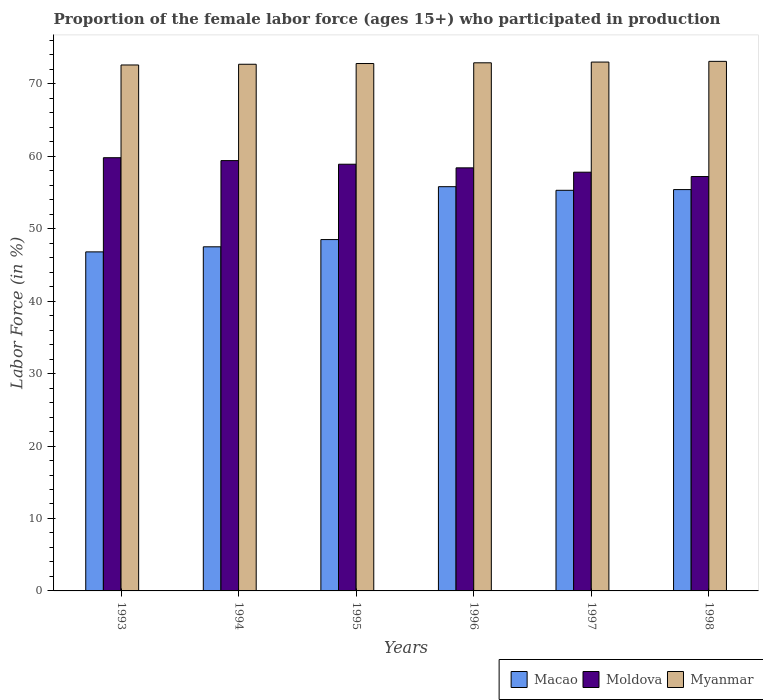How many different coloured bars are there?
Your response must be concise. 3. How many groups of bars are there?
Give a very brief answer. 6. Are the number of bars per tick equal to the number of legend labels?
Your answer should be very brief. Yes. How many bars are there on the 5th tick from the left?
Your response must be concise. 3. How many bars are there on the 6th tick from the right?
Keep it short and to the point. 3. What is the proportion of the female labor force who participated in production in Macao in 1996?
Give a very brief answer. 55.8. Across all years, what is the maximum proportion of the female labor force who participated in production in Moldova?
Ensure brevity in your answer.  59.8. Across all years, what is the minimum proportion of the female labor force who participated in production in Myanmar?
Your answer should be compact. 72.6. What is the total proportion of the female labor force who participated in production in Macao in the graph?
Offer a very short reply. 309.3. What is the difference between the proportion of the female labor force who participated in production in Myanmar in 1998 and the proportion of the female labor force who participated in production in Moldova in 1996?
Your answer should be very brief. 14.7. What is the average proportion of the female labor force who participated in production in Macao per year?
Provide a succinct answer. 51.55. In the year 1997, what is the difference between the proportion of the female labor force who participated in production in Macao and proportion of the female labor force who participated in production in Myanmar?
Offer a terse response. -17.7. In how many years, is the proportion of the female labor force who participated in production in Moldova greater than 56 %?
Provide a succinct answer. 6. What is the ratio of the proportion of the female labor force who participated in production in Myanmar in 1993 to that in 1996?
Your answer should be very brief. 1. Is the proportion of the female labor force who participated in production in Moldova in 1996 less than that in 1997?
Make the answer very short. No. What is the difference between the highest and the second highest proportion of the female labor force who participated in production in Macao?
Make the answer very short. 0.4. What does the 1st bar from the left in 1997 represents?
Provide a succinct answer. Macao. What does the 2nd bar from the right in 1996 represents?
Provide a short and direct response. Moldova. Is it the case that in every year, the sum of the proportion of the female labor force who participated in production in Macao and proportion of the female labor force who participated in production in Myanmar is greater than the proportion of the female labor force who participated in production in Moldova?
Offer a very short reply. Yes. How many years are there in the graph?
Keep it short and to the point. 6. What is the difference between two consecutive major ticks on the Y-axis?
Provide a succinct answer. 10. Does the graph contain grids?
Provide a succinct answer. No. Where does the legend appear in the graph?
Make the answer very short. Bottom right. What is the title of the graph?
Your answer should be very brief. Proportion of the female labor force (ages 15+) who participated in production. What is the Labor Force (in %) of Macao in 1993?
Your answer should be compact. 46.8. What is the Labor Force (in %) of Moldova in 1993?
Your response must be concise. 59.8. What is the Labor Force (in %) in Myanmar in 1993?
Provide a short and direct response. 72.6. What is the Labor Force (in %) of Macao in 1994?
Your answer should be very brief. 47.5. What is the Labor Force (in %) of Moldova in 1994?
Offer a terse response. 59.4. What is the Labor Force (in %) of Myanmar in 1994?
Your answer should be very brief. 72.7. What is the Labor Force (in %) in Macao in 1995?
Offer a terse response. 48.5. What is the Labor Force (in %) in Moldova in 1995?
Provide a succinct answer. 58.9. What is the Labor Force (in %) in Myanmar in 1995?
Offer a terse response. 72.8. What is the Labor Force (in %) in Macao in 1996?
Keep it short and to the point. 55.8. What is the Labor Force (in %) of Moldova in 1996?
Provide a succinct answer. 58.4. What is the Labor Force (in %) in Myanmar in 1996?
Ensure brevity in your answer.  72.9. What is the Labor Force (in %) in Macao in 1997?
Your answer should be very brief. 55.3. What is the Labor Force (in %) in Moldova in 1997?
Provide a short and direct response. 57.8. What is the Labor Force (in %) in Myanmar in 1997?
Provide a succinct answer. 73. What is the Labor Force (in %) of Macao in 1998?
Your answer should be compact. 55.4. What is the Labor Force (in %) in Moldova in 1998?
Ensure brevity in your answer.  57.2. What is the Labor Force (in %) of Myanmar in 1998?
Provide a short and direct response. 73.1. Across all years, what is the maximum Labor Force (in %) of Macao?
Your answer should be very brief. 55.8. Across all years, what is the maximum Labor Force (in %) of Moldova?
Provide a short and direct response. 59.8. Across all years, what is the maximum Labor Force (in %) of Myanmar?
Ensure brevity in your answer.  73.1. Across all years, what is the minimum Labor Force (in %) of Macao?
Ensure brevity in your answer.  46.8. Across all years, what is the minimum Labor Force (in %) in Moldova?
Make the answer very short. 57.2. Across all years, what is the minimum Labor Force (in %) in Myanmar?
Offer a very short reply. 72.6. What is the total Labor Force (in %) in Macao in the graph?
Your answer should be very brief. 309.3. What is the total Labor Force (in %) in Moldova in the graph?
Keep it short and to the point. 351.5. What is the total Labor Force (in %) in Myanmar in the graph?
Your answer should be very brief. 437.1. What is the difference between the Labor Force (in %) of Macao in 1993 and that in 1994?
Offer a very short reply. -0.7. What is the difference between the Labor Force (in %) of Moldova in 1993 and that in 1995?
Offer a very short reply. 0.9. What is the difference between the Labor Force (in %) of Myanmar in 1993 and that in 1995?
Your response must be concise. -0.2. What is the difference between the Labor Force (in %) of Macao in 1993 and that in 1996?
Ensure brevity in your answer.  -9. What is the difference between the Labor Force (in %) of Moldova in 1993 and that in 1996?
Your answer should be compact. 1.4. What is the difference between the Labor Force (in %) in Moldova in 1993 and that in 1998?
Your response must be concise. 2.6. What is the difference between the Labor Force (in %) in Myanmar in 1993 and that in 1998?
Provide a succinct answer. -0.5. What is the difference between the Labor Force (in %) of Moldova in 1994 and that in 1995?
Provide a short and direct response. 0.5. What is the difference between the Labor Force (in %) of Myanmar in 1994 and that in 1995?
Provide a short and direct response. -0.1. What is the difference between the Labor Force (in %) in Myanmar in 1994 and that in 1996?
Provide a succinct answer. -0.2. What is the difference between the Labor Force (in %) in Macao in 1994 and that in 1997?
Provide a short and direct response. -7.8. What is the difference between the Labor Force (in %) in Moldova in 1994 and that in 1997?
Your response must be concise. 1.6. What is the difference between the Labor Force (in %) of Myanmar in 1994 and that in 1997?
Keep it short and to the point. -0.3. What is the difference between the Labor Force (in %) of Moldova in 1994 and that in 1998?
Make the answer very short. 2.2. What is the difference between the Labor Force (in %) of Myanmar in 1994 and that in 1998?
Your answer should be very brief. -0.4. What is the difference between the Labor Force (in %) of Macao in 1995 and that in 1996?
Your answer should be compact. -7.3. What is the difference between the Labor Force (in %) of Macao in 1995 and that in 1998?
Keep it short and to the point. -6.9. What is the difference between the Labor Force (in %) in Moldova in 1995 and that in 1998?
Offer a very short reply. 1.7. What is the difference between the Labor Force (in %) in Moldova in 1996 and that in 1997?
Offer a very short reply. 0.6. What is the difference between the Labor Force (in %) of Myanmar in 1996 and that in 1997?
Provide a short and direct response. -0.1. What is the difference between the Labor Force (in %) of Moldova in 1996 and that in 1998?
Ensure brevity in your answer.  1.2. What is the difference between the Labor Force (in %) in Myanmar in 1996 and that in 1998?
Give a very brief answer. -0.2. What is the difference between the Labor Force (in %) in Myanmar in 1997 and that in 1998?
Your response must be concise. -0.1. What is the difference between the Labor Force (in %) in Macao in 1993 and the Labor Force (in %) in Moldova in 1994?
Your answer should be compact. -12.6. What is the difference between the Labor Force (in %) in Macao in 1993 and the Labor Force (in %) in Myanmar in 1994?
Your response must be concise. -25.9. What is the difference between the Labor Force (in %) in Macao in 1993 and the Labor Force (in %) in Moldova in 1995?
Offer a terse response. -12.1. What is the difference between the Labor Force (in %) in Moldova in 1993 and the Labor Force (in %) in Myanmar in 1995?
Ensure brevity in your answer.  -13. What is the difference between the Labor Force (in %) in Macao in 1993 and the Labor Force (in %) in Myanmar in 1996?
Make the answer very short. -26.1. What is the difference between the Labor Force (in %) in Macao in 1993 and the Labor Force (in %) in Myanmar in 1997?
Ensure brevity in your answer.  -26.2. What is the difference between the Labor Force (in %) in Macao in 1993 and the Labor Force (in %) in Moldova in 1998?
Provide a succinct answer. -10.4. What is the difference between the Labor Force (in %) in Macao in 1993 and the Labor Force (in %) in Myanmar in 1998?
Make the answer very short. -26.3. What is the difference between the Labor Force (in %) in Macao in 1994 and the Labor Force (in %) in Myanmar in 1995?
Make the answer very short. -25.3. What is the difference between the Labor Force (in %) in Macao in 1994 and the Labor Force (in %) in Myanmar in 1996?
Give a very brief answer. -25.4. What is the difference between the Labor Force (in %) in Macao in 1994 and the Labor Force (in %) in Myanmar in 1997?
Ensure brevity in your answer.  -25.5. What is the difference between the Labor Force (in %) in Macao in 1994 and the Labor Force (in %) in Myanmar in 1998?
Your answer should be very brief. -25.6. What is the difference between the Labor Force (in %) in Moldova in 1994 and the Labor Force (in %) in Myanmar in 1998?
Provide a short and direct response. -13.7. What is the difference between the Labor Force (in %) in Macao in 1995 and the Labor Force (in %) in Moldova in 1996?
Give a very brief answer. -9.9. What is the difference between the Labor Force (in %) of Macao in 1995 and the Labor Force (in %) of Myanmar in 1996?
Ensure brevity in your answer.  -24.4. What is the difference between the Labor Force (in %) in Moldova in 1995 and the Labor Force (in %) in Myanmar in 1996?
Keep it short and to the point. -14. What is the difference between the Labor Force (in %) of Macao in 1995 and the Labor Force (in %) of Myanmar in 1997?
Make the answer very short. -24.5. What is the difference between the Labor Force (in %) in Moldova in 1995 and the Labor Force (in %) in Myanmar in 1997?
Provide a succinct answer. -14.1. What is the difference between the Labor Force (in %) in Macao in 1995 and the Labor Force (in %) in Myanmar in 1998?
Ensure brevity in your answer.  -24.6. What is the difference between the Labor Force (in %) of Moldova in 1995 and the Labor Force (in %) of Myanmar in 1998?
Offer a very short reply. -14.2. What is the difference between the Labor Force (in %) in Macao in 1996 and the Labor Force (in %) in Moldova in 1997?
Keep it short and to the point. -2. What is the difference between the Labor Force (in %) in Macao in 1996 and the Labor Force (in %) in Myanmar in 1997?
Provide a succinct answer. -17.2. What is the difference between the Labor Force (in %) of Moldova in 1996 and the Labor Force (in %) of Myanmar in 1997?
Offer a very short reply. -14.6. What is the difference between the Labor Force (in %) in Macao in 1996 and the Labor Force (in %) in Moldova in 1998?
Provide a short and direct response. -1.4. What is the difference between the Labor Force (in %) of Macao in 1996 and the Labor Force (in %) of Myanmar in 1998?
Offer a terse response. -17.3. What is the difference between the Labor Force (in %) in Moldova in 1996 and the Labor Force (in %) in Myanmar in 1998?
Ensure brevity in your answer.  -14.7. What is the difference between the Labor Force (in %) in Macao in 1997 and the Labor Force (in %) in Myanmar in 1998?
Make the answer very short. -17.8. What is the difference between the Labor Force (in %) in Moldova in 1997 and the Labor Force (in %) in Myanmar in 1998?
Ensure brevity in your answer.  -15.3. What is the average Labor Force (in %) in Macao per year?
Your response must be concise. 51.55. What is the average Labor Force (in %) of Moldova per year?
Provide a succinct answer. 58.58. What is the average Labor Force (in %) of Myanmar per year?
Offer a very short reply. 72.85. In the year 1993, what is the difference between the Labor Force (in %) in Macao and Labor Force (in %) in Myanmar?
Offer a very short reply. -25.8. In the year 1994, what is the difference between the Labor Force (in %) in Macao and Labor Force (in %) in Myanmar?
Make the answer very short. -25.2. In the year 1994, what is the difference between the Labor Force (in %) in Moldova and Labor Force (in %) in Myanmar?
Your response must be concise. -13.3. In the year 1995, what is the difference between the Labor Force (in %) in Macao and Labor Force (in %) in Myanmar?
Ensure brevity in your answer.  -24.3. In the year 1995, what is the difference between the Labor Force (in %) of Moldova and Labor Force (in %) of Myanmar?
Your response must be concise. -13.9. In the year 1996, what is the difference between the Labor Force (in %) of Macao and Labor Force (in %) of Myanmar?
Your answer should be very brief. -17.1. In the year 1996, what is the difference between the Labor Force (in %) in Moldova and Labor Force (in %) in Myanmar?
Your response must be concise. -14.5. In the year 1997, what is the difference between the Labor Force (in %) in Macao and Labor Force (in %) in Moldova?
Your response must be concise. -2.5. In the year 1997, what is the difference between the Labor Force (in %) in Macao and Labor Force (in %) in Myanmar?
Give a very brief answer. -17.7. In the year 1997, what is the difference between the Labor Force (in %) in Moldova and Labor Force (in %) in Myanmar?
Your answer should be very brief. -15.2. In the year 1998, what is the difference between the Labor Force (in %) in Macao and Labor Force (in %) in Moldova?
Your answer should be very brief. -1.8. In the year 1998, what is the difference between the Labor Force (in %) of Macao and Labor Force (in %) of Myanmar?
Your answer should be compact. -17.7. In the year 1998, what is the difference between the Labor Force (in %) of Moldova and Labor Force (in %) of Myanmar?
Your answer should be compact. -15.9. What is the ratio of the Labor Force (in %) in Moldova in 1993 to that in 1994?
Your answer should be very brief. 1.01. What is the ratio of the Labor Force (in %) of Macao in 1993 to that in 1995?
Provide a succinct answer. 0.96. What is the ratio of the Labor Force (in %) of Moldova in 1993 to that in 1995?
Your answer should be very brief. 1.02. What is the ratio of the Labor Force (in %) in Myanmar in 1993 to that in 1995?
Make the answer very short. 1. What is the ratio of the Labor Force (in %) in Macao in 1993 to that in 1996?
Offer a very short reply. 0.84. What is the ratio of the Labor Force (in %) in Macao in 1993 to that in 1997?
Provide a short and direct response. 0.85. What is the ratio of the Labor Force (in %) of Moldova in 1993 to that in 1997?
Give a very brief answer. 1.03. What is the ratio of the Labor Force (in %) of Macao in 1993 to that in 1998?
Make the answer very short. 0.84. What is the ratio of the Labor Force (in %) in Moldova in 1993 to that in 1998?
Offer a terse response. 1.05. What is the ratio of the Labor Force (in %) in Macao in 1994 to that in 1995?
Your response must be concise. 0.98. What is the ratio of the Labor Force (in %) of Moldova in 1994 to that in 1995?
Keep it short and to the point. 1.01. What is the ratio of the Labor Force (in %) in Myanmar in 1994 to that in 1995?
Provide a succinct answer. 1. What is the ratio of the Labor Force (in %) in Macao in 1994 to that in 1996?
Provide a succinct answer. 0.85. What is the ratio of the Labor Force (in %) of Moldova in 1994 to that in 1996?
Keep it short and to the point. 1.02. What is the ratio of the Labor Force (in %) in Myanmar in 1994 to that in 1996?
Offer a very short reply. 1. What is the ratio of the Labor Force (in %) in Macao in 1994 to that in 1997?
Your response must be concise. 0.86. What is the ratio of the Labor Force (in %) in Moldova in 1994 to that in 1997?
Your response must be concise. 1.03. What is the ratio of the Labor Force (in %) in Macao in 1994 to that in 1998?
Your answer should be compact. 0.86. What is the ratio of the Labor Force (in %) of Macao in 1995 to that in 1996?
Give a very brief answer. 0.87. What is the ratio of the Labor Force (in %) of Moldova in 1995 to that in 1996?
Provide a succinct answer. 1.01. What is the ratio of the Labor Force (in %) of Myanmar in 1995 to that in 1996?
Offer a terse response. 1. What is the ratio of the Labor Force (in %) in Macao in 1995 to that in 1997?
Offer a terse response. 0.88. What is the ratio of the Labor Force (in %) of Moldova in 1995 to that in 1997?
Your response must be concise. 1.02. What is the ratio of the Labor Force (in %) in Macao in 1995 to that in 1998?
Provide a succinct answer. 0.88. What is the ratio of the Labor Force (in %) in Moldova in 1995 to that in 1998?
Offer a terse response. 1.03. What is the ratio of the Labor Force (in %) of Moldova in 1996 to that in 1997?
Make the answer very short. 1.01. What is the ratio of the Labor Force (in %) of Myanmar in 1996 to that in 1997?
Make the answer very short. 1. What is the ratio of the Labor Force (in %) of Myanmar in 1996 to that in 1998?
Make the answer very short. 1. What is the ratio of the Labor Force (in %) in Macao in 1997 to that in 1998?
Ensure brevity in your answer.  1. What is the ratio of the Labor Force (in %) in Moldova in 1997 to that in 1998?
Provide a succinct answer. 1.01. What is the ratio of the Labor Force (in %) in Myanmar in 1997 to that in 1998?
Keep it short and to the point. 1. What is the difference between the highest and the second highest Labor Force (in %) of Myanmar?
Your answer should be compact. 0.1. What is the difference between the highest and the lowest Labor Force (in %) of Moldova?
Provide a short and direct response. 2.6. What is the difference between the highest and the lowest Labor Force (in %) of Myanmar?
Your answer should be compact. 0.5. 